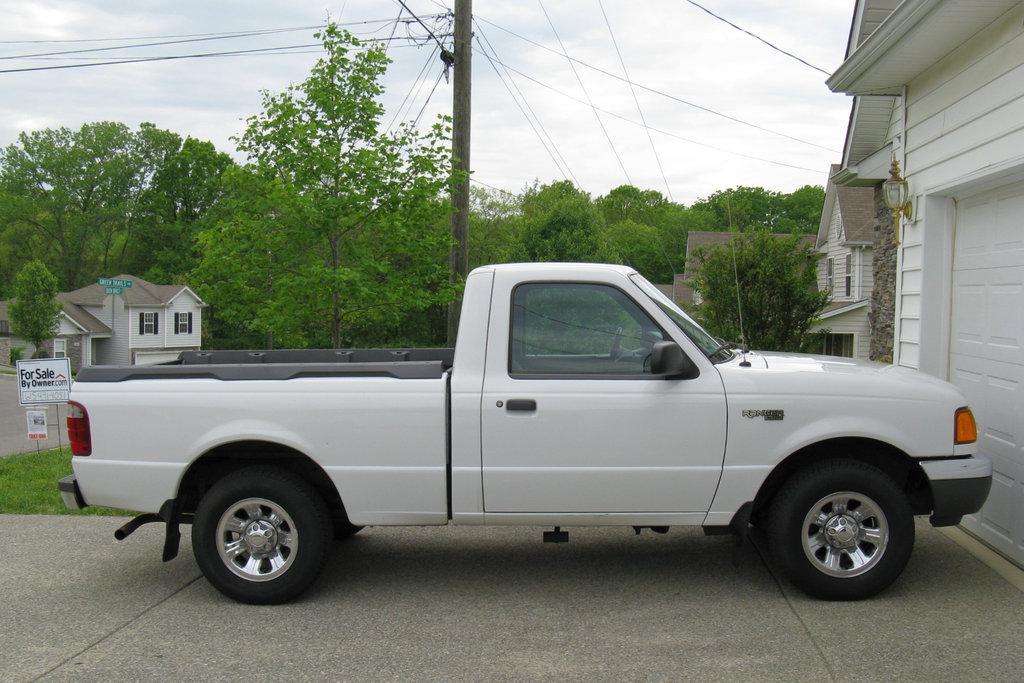How would you summarize this image in a sentence or two? In this image I can see a vehicle in white color. Background I can see few houses in white color, trees in green color and the sky is in white color. 